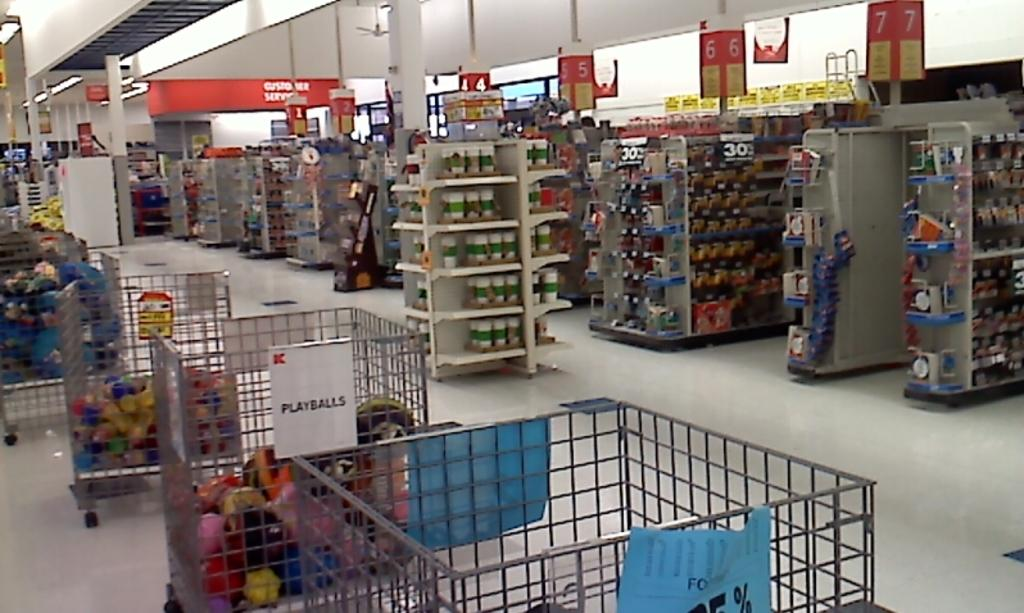Provide a one-sentence caption for the provided image. inside of k-mart store and clearly visible is metal bin full of playballs. 